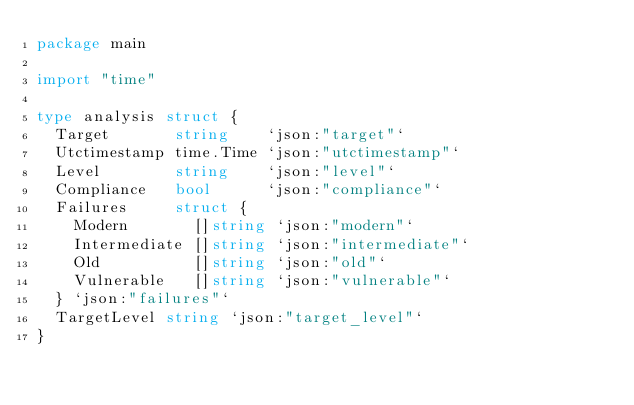Convert code to text. <code><loc_0><loc_0><loc_500><loc_500><_Go_>package main

import "time"

type analysis struct {
	Target       string    `json:"target"`
	Utctimestamp time.Time `json:"utctimestamp"`
	Level        string    `json:"level"`
	Compliance   bool      `json:"compliance"`
	Failures     struct {
		Modern       []string `json:"modern"`
		Intermediate []string `json:"intermediate"`
		Old          []string `json:"old"`
		Vulnerable   []string `json:"vulnerable"`
	} `json:"failures"`
	TargetLevel string `json:"target_level"`
}
</code> 